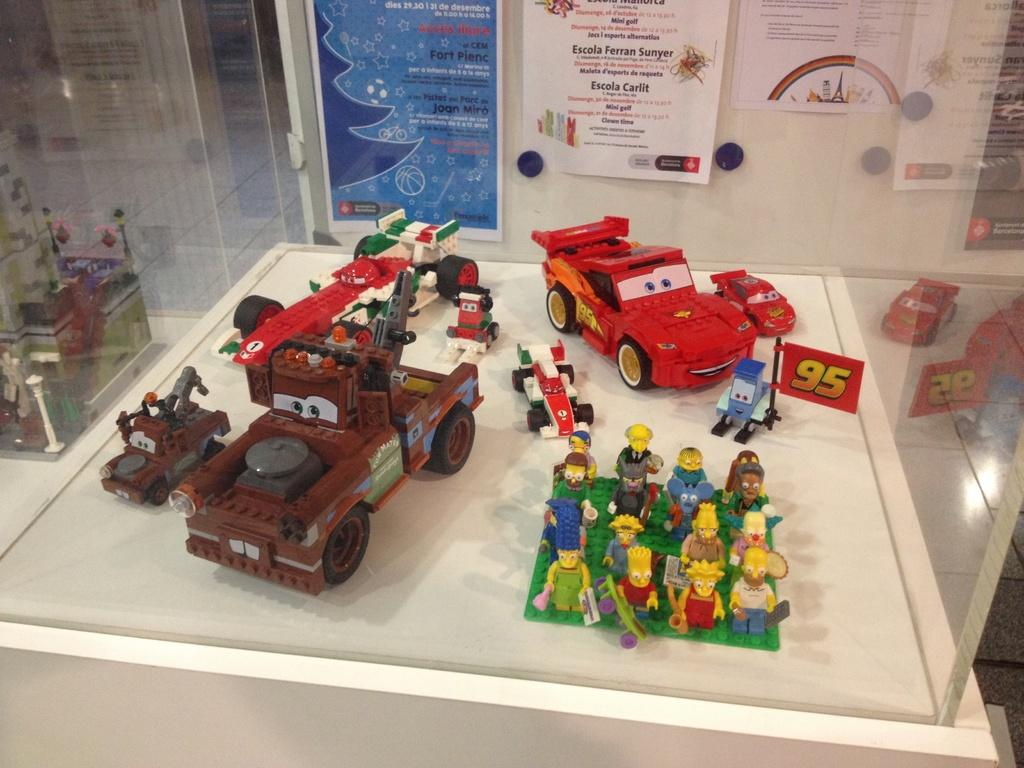What is the main subject of the image? The main subject of the image is a group of toys. How are the toys arranged in the image? The toys are placed inside a glass container. What can be seen in the background of the image? There are papers with text on a wall in the background of the image. Can you tell me how many zebras are in the image? There are no zebras present in the image. What is the woman doing in the image? There is no woman present in the image. 